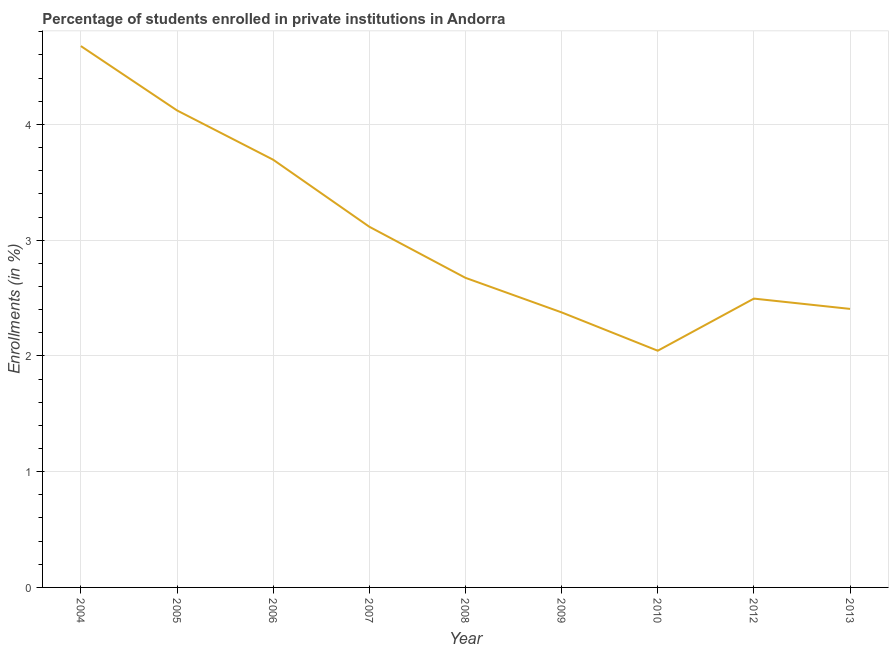What is the enrollments in private institutions in 2006?
Offer a terse response. 3.7. Across all years, what is the maximum enrollments in private institutions?
Ensure brevity in your answer.  4.68. Across all years, what is the minimum enrollments in private institutions?
Offer a very short reply. 2.04. In which year was the enrollments in private institutions minimum?
Keep it short and to the point. 2010. What is the sum of the enrollments in private institutions?
Ensure brevity in your answer.  27.61. What is the difference between the enrollments in private institutions in 2008 and 2013?
Ensure brevity in your answer.  0.27. What is the average enrollments in private institutions per year?
Make the answer very short. 3.07. What is the median enrollments in private institutions?
Offer a very short reply. 2.67. Do a majority of the years between 2013 and 2009 (inclusive) have enrollments in private institutions greater than 0.8 %?
Offer a terse response. Yes. What is the ratio of the enrollments in private institutions in 2008 to that in 2012?
Your answer should be very brief. 1.07. What is the difference between the highest and the second highest enrollments in private institutions?
Provide a short and direct response. 0.56. What is the difference between the highest and the lowest enrollments in private institutions?
Your response must be concise. 2.63. Does the graph contain any zero values?
Give a very brief answer. No. What is the title of the graph?
Keep it short and to the point. Percentage of students enrolled in private institutions in Andorra. What is the label or title of the Y-axis?
Your answer should be compact. Enrollments (in %). What is the Enrollments (in %) of 2004?
Offer a terse response. 4.68. What is the Enrollments (in %) of 2005?
Your answer should be compact. 4.12. What is the Enrollments (in %) of 2006?
Your answer should be compact. 3.7. What is the Enrollments (in %) in 2007?
Give a very brief answer. 3.12. What is the Enrollments (in %) of 2008?
Offer a terse response. 2.67. What is the Enrollments (in %) in 2009?
Offer a very short reply. 2.38. What is the Enrollments (in %) of 2010?
Your answer should be compact. 2.04. What is the Enrollments (in %) of 2012?
Offer a very short reply. 2.5. What is the Enrollments (in %) of 2013?
Give a very brief answer. 2.41. What is the difference between the Enrollments (in %) in 2004 and 2005?
Give a very brief answer. 0.56. What is the difference between the Enrollments (in %) in 2004 and 2006?
Ensure brevity in your answer.  0.98. What is the difference between the Enrollments (in %) in 2004 and 2007?
Provide a succinct answer. 1.56. What is the difference between the Enrollments (in %) in 2004 and 2008?
Your answer should be very brief. 2. What is the difference between the Enrollments (in %) in 2004 and 2009?
Make the answer very short. 2.3. What is the difference between the Enrollments (in %) in 2004 and 2010?
Offer a terse response. 2.63. What is the difference between the Enrollments (in %) in 2004 and 2012?
Your answer should be very brief. 2.18. What is the difference between the Enrollments (in %) in 2004 and 2013?
Provide a short and direct response. 2.27. What is the difference between the Enrollments (in %) in 2005 and 2006?
Your answer should be very brief. 0.43. What is the difference between the Enrollments (in %) in 2005 and 2007?
Your answer should be compact. 1. What is the difference between the Enrollments (in %) in 2005 and 2008?
Give a very brief answer. 1.45. What is the difference between the Enrollments (in %) in 2005 and 2009?
Provide a short and direct response. 1.74. What is the difference between the Enrollments (in %) in 2005 and 2010?
Your response must be concise. 2.08. What is the difference between the Enrollments (in %) in 2005 and 2012?
Give a very brief answer. 1.63. What is the difference between the Enrollments (in %) in 2005 and 2013?
Make the answer very short. 1.71. What is the difference between the Enrollments (in %) in 2006 and 2007?
Your answer should be very brief. 0.58. What is the difference between the Enrollments (in %) in 2006 and 2008?
Keep it short and to the point. 1.02. What is the difference between the Enrollments (in %) in 2006 and 2009?
Your answer should be compact. 1.32. What is the difference between the Enrollments (in %) in 2006 and 2010?
Offer a terse response. 1.65. What is the difference between the Enrollments (in %) in 2006 and 2012?
Offer a very short reply. 1.2. What is the difference between the Enrollments (in %) in 2006 and 2013?
Make the answer very short. 1.29. What is the difference between the Enrollments (in %) in 2007 and 2008?
Make the answer very short. 0.44. What is the difference between the Enrollments (in %) in 2007 and 2009?
Your answer should be compact. 0.74. What is the difference between the Enrollments (in %) in 2007 and 2010?
Keep it short and to the point. 1.07. What is the difference between the Enrollments (in %) in 2007 and 2012?
Provide a succinct answer. 0.62. What is the difference between the Enrollments (in %) in 2007 and 2013?
Ensure brevity in your answer.  0.71. What is the difference between the Enrollments (in %) in 2008 and 2009?
Give a very brief answer. 0.3. What is the difference between the Enrollments (in %) in 2008 and 2010?
Offer a terse response. 0.63. What is the difference between the Enrollments (in %) in 2008 and 2012?
Make the answer very short. 0.18. What is the difference between the Enrollments (in %) in 2008 and 2013?
Provide a short and direct response. 0.27. What is the difference between the Enrollments (in %) in 2009 and 2010?
Provide a succinct answer. 0.33. What is the difference between the Enrollments (in %) in 2009 and 2012?
Give a very brief answer. -0.12. What is the difference between the Enrollments (in %) in 2009 and 2013?
Provide a short and direct response. -0.03. What is the difference between the Enrollments (in %) in 2010 and 2012?
Offer a terse response. -0.45. What is the difference between the Enrollments (in %) in 2010 and 2013?
Keep it short and to the point. -0.36. What is the difference between the Enrollments (in %) in 2012 and 2013?
Your response must be concise. 0.09. What is the ratio of the Enrollments (in %) in 2004 to that in 2005?
Your answer should be very brief. 1.14. What is the ratio of the Enrollments (in %) in 2004 to that in 2006?
Make the answer very short. 1.27. What is the ratio of the Enrollments (in %) in 2004 to that in 2007?
Give a very brief answer. 1.5. What is the ratio of the Enrollments (in %) in 2004 to that in 2008?
Your answer should be very brief. 1.75. What is the ratio of the Enrollments (in %) in 2004 to that in 2009?
Your answer should be very brief. 1.97. What is the ratio of the Enrollments (in %) in 2004 to that in 2010?
Keep it short and to the point. 2.29. What is the ratio of the Enrollments (in %) in 2004 to that in 2012?
Your answer should be compact. 1.87. What is the ratio of the Enrollments (in %) in 2004 to that in 2013?
Provide a succinct answer. 1.94. What is the ratio of the Enrollments (in %) in 2005 to that in 2006?
Give a very brief answer. 1.11. What is the ratio of the Enrollments (in %) in 2005 to that in 2007?
Provide a succinct answer. 1.32. What is the ratio of the Enrollments (in %) in 2005 to that in 2008?
Your answer should be compact. 1.54. What is the ratio of the Enrollments (in %) in 2005 to that in 2009?
Make the answer very short. 1.73. What is the ratio of the Enrollments (in %) in 2005 to that in 2010?
Offer a terse response. 2.02. What is the ratio of the Enrollments (in %) in 2005 to that in 2012?
Make the answer very short. 1.65. What is the ratio of the Enrollments (in %) in 2005 to that in 2013?
Your answer should be compact. 1.71. What is the ratio of the Enrollments (in %) in 2006 to that in 2007?
Provide a succinct answer. 1.19. What is the ratio of the Enrollments (in %) in 2006 to that in 2008?
Ensure brevity in your answer.  1.38. What is the ratio of the Enrollments (in %) in 2006 to that in 2009?
Your answer should be compact. 1.55. What is the ratio of the Enrollments (in %) in 2006 to that in 2010?
Offer a terse response. 1.81. What is the ratio of the Enrollments (in %) in 2006 to that in 2012?
Offer a very short reply. 1.48. What is the ratio of the Enrollments (in %) in 2006 to that in 2013?
Your answer should be compact. 1.54. What is the ratio of the Enrollments (in %) in 2007 to that in 2008?
Your answer should be compact. 1.17. What is the ratio of the Enrollments (in %) in 2007 to that in 2009?
Offer a terse response. 1.31. What is the ratio of the Enrollments (in %) in 2007 to that in 2010?
Offer a very short reply. 1.52. What is the ratio of the Enrollments (in %) in 2007 to that in 2012?
Offer a terse response. 1.25. What is the ratio of the Enrollments (in %) in 2007 to that in 2013?
Ensure brevity in your answer.  1.29. What is the ratio of the Enrollments (in %) in 2008 to that in 2009?
Your answer should be very brief. 1.13. What is the ratio of the Enrollments (in %) in 2008 to that in 2010?
Your answer should be compact. 1.31. What is the ratio of the Enrollments (in %) in 2008 to that in 2012?
Make the answer very short. 1.07. What is the ratio of the Enrollments (in %) in 2008 to that in 2013?
Offer a terse response. 1.11. What is the ratio of the Enrollments (in %) in 2009 to that in 2010?
Provide a succinct answer. 1.16. What is the ratio of the Enrollments (in %) in 2010 to that in 2012?
Your answer should be compact. 0.82. What is the ratio of the Enrollments (in %) in 2012 to that in 2013?
Make the answer very short. 1.04. 